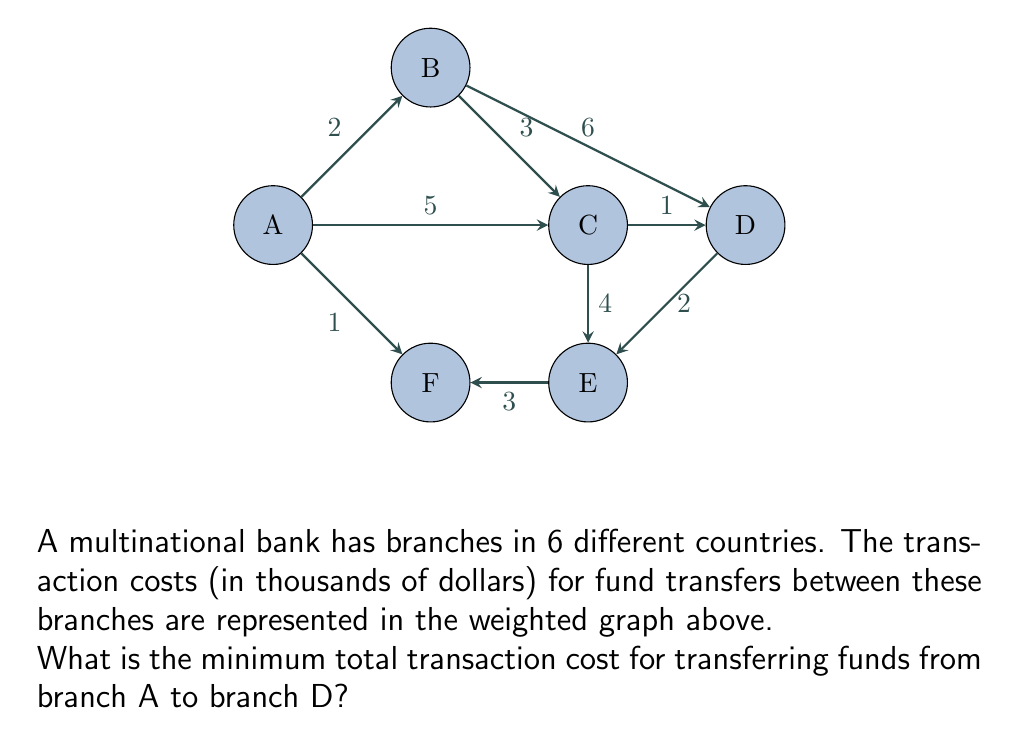What is the answer to this math problem? To solve this problem, we need to find the shortest path from node A to node D in the given weighted graph. We can use Dijkstra's algorithm to find the shortest path.

Step 1: Initialize distances
Set distance to A as 0 and all other nodes as infinity.
$d(A) = 0$, $d(B) = d(C) = d(D) = d(E) = d(F) = \infty$

Step 2: Visit node A
Update distances:
$d(B) = 2$, $d(C) = 5$, $d(F) = 1$

Step 3: Visit node F (closest unvisited node)
Update distances:
No changes (F is not connected to unvisited nodes with shorter paths)

Step 4: Visit node B
Update distances:
$d(C) = \min(5, 2 + 3) = 5$
$d(D) = \min(\infty, 2 + 6) = 8$

Step 5: Visit node C
Update distances:
$d(D) = \min(8, 5 + 1) = 6$

Step 6: Visit node D
We've reached the destination node. The shortest path is found.

The shortest path from A to D is A → C → D with a total cost of 6 (5 + 1).
Answer: $6,000 